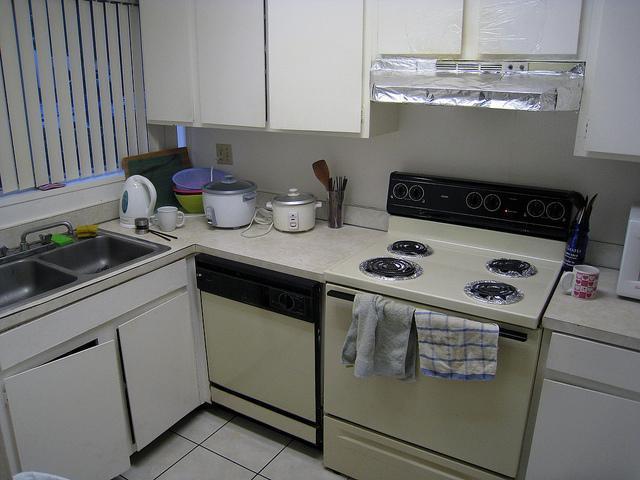How many pots are on the stove?
Give a very brief answer. 0. How many black knobs are there?
Give a very brief answer. 6. 